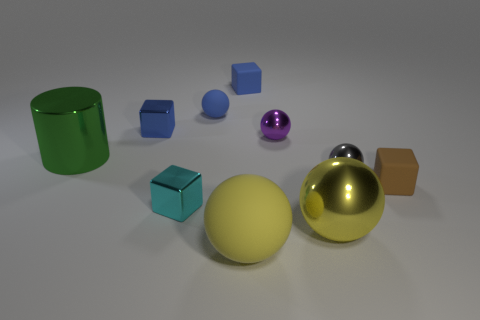Subtract 2 spheres. How many spheres are left? 3 Subtract all cyan balls. Subtract all yellow cubes. How many balls are left? 5 Subtract all blocks. How many objects are left? 6 Subtract 0 gray cylinders. How many objects are left? 10 Subtract all cyan objects. Subtract all large metal things. How many objects are left? 7 Add 5 big spheres. How many big spheres are left? 7 Add 4 large green metallic cylinders. How many large green metallic cylinders exist? 5 